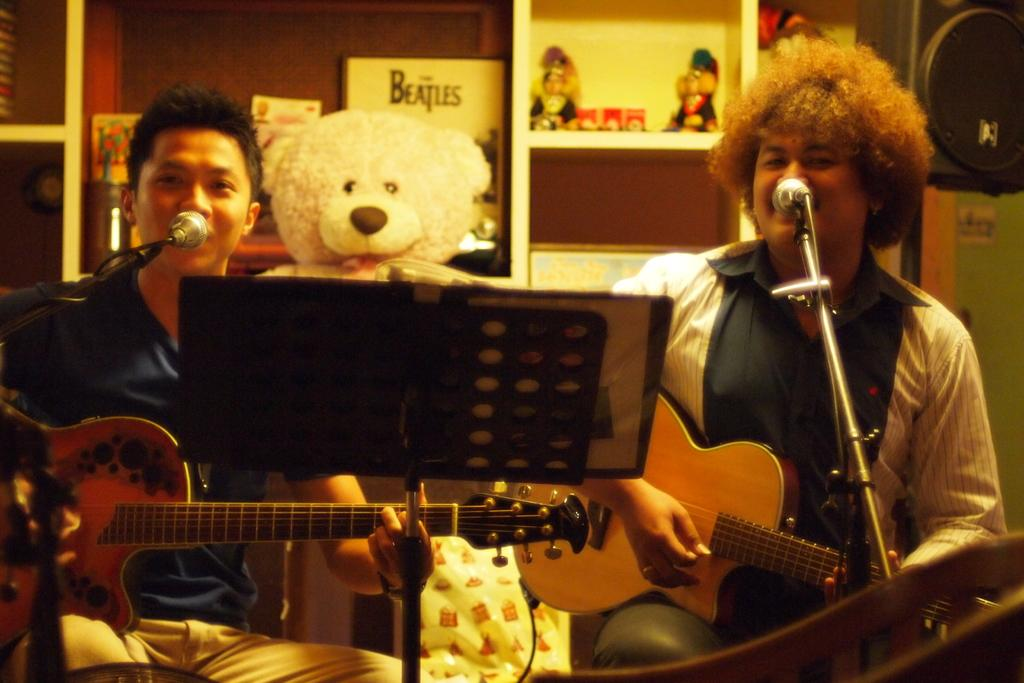How many people are in the image? There are two men in the image. What are the men doing in the image? The men are playing guitar and singing. What object is used for amplifying their voices? A microphone is present in the image. What item can be seen holding a book or sheet music? There is a book stand in the image. What additional object can be seen in the image? A soft toy is visible in the image. What type of servant is attending to the men in the image? There is no servant present in the image; it only features the two men, their instruments, and other objects. What type of frame surrounds the image? The image does not have a frame; the question refers to the physical representation of the image, not the content within it. 